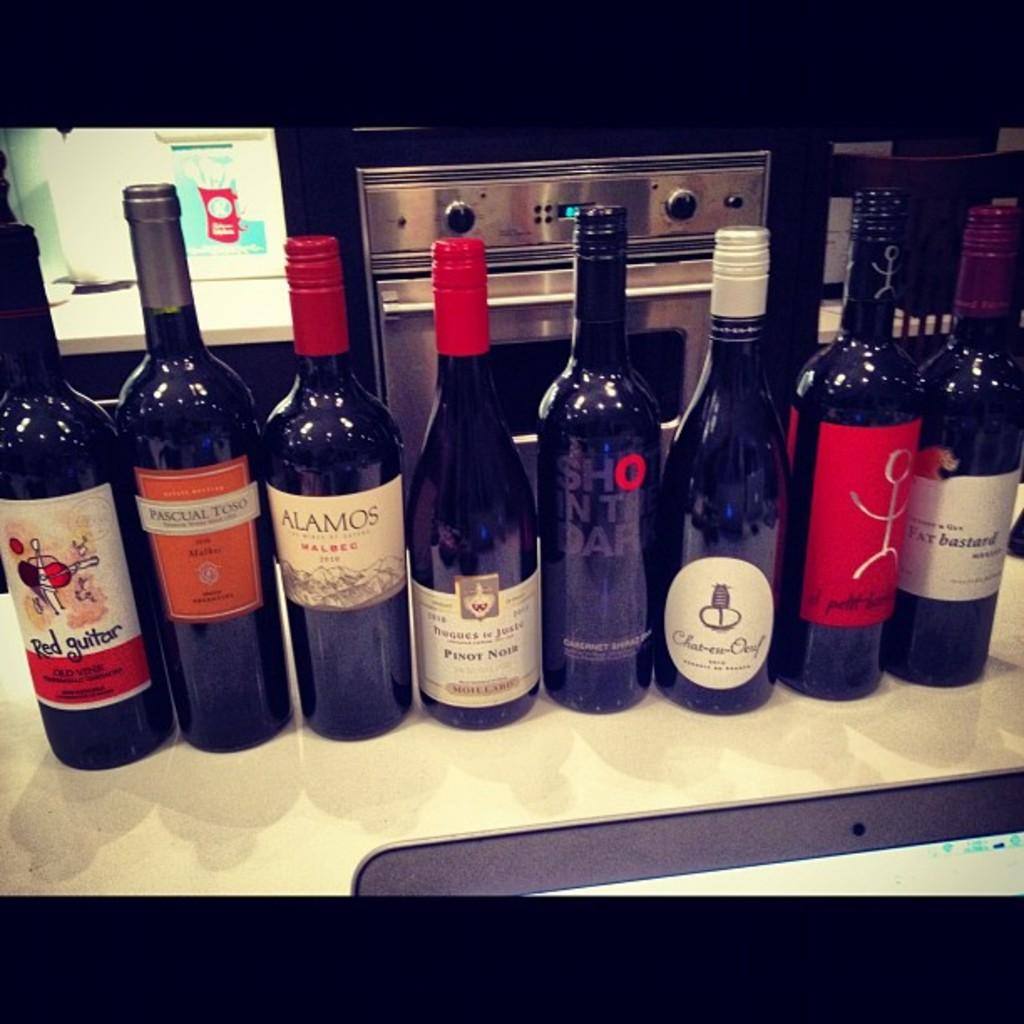<image>
Write a terse but informative summary of the picture. Many different wine bottles with one labeled Alamos 